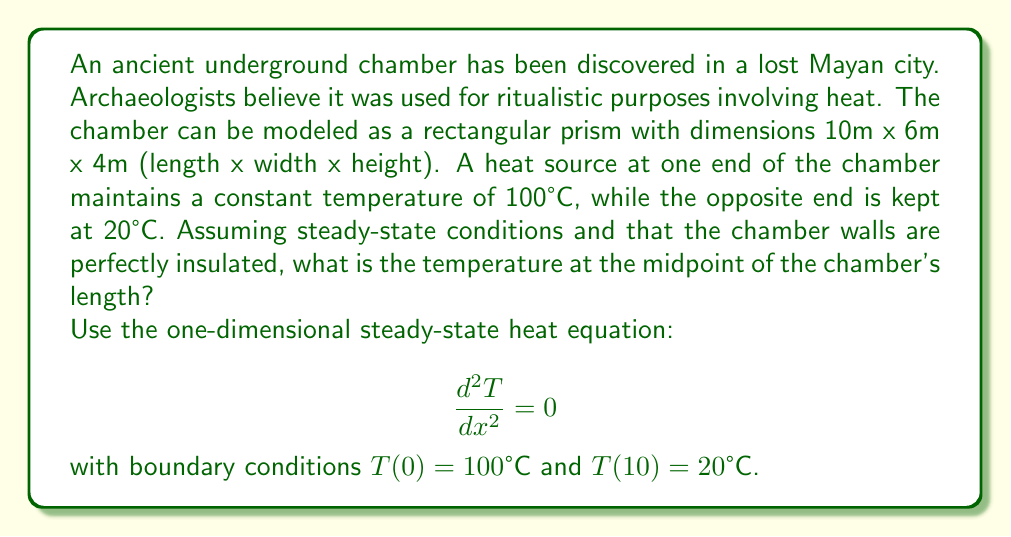Can you answer this question? To solve this problem, we'll follow these steps:

1) The general solution to the steady-state heat equation is:

   $$T(x) = Ax + B$$

   where $A$ and $B$ are constants to be determined.

2) Apply the boundary conditions:
   At $x = 0$: $T(0) = 100°C = B$
   At $x = 10$: $T(10) = 20°C = 10A + B$

3) Substitute $B = 100$ into the second equation:
   $20 = 10A + 100$
   $-80 = 10A$
   $A = -8$

4) Therefore, the temperature distribution is given by:
   $$T(x) = -8x + 100$$

5) To find the temperature at the midpoint, we calculate $T(5)$:
   $$T(5) = -8(5) + 100 = -40 + 100 = 60°C$$

Thus, the temperature at the midpoint of the chamber's length is 60°C.
Answer: 60°C 